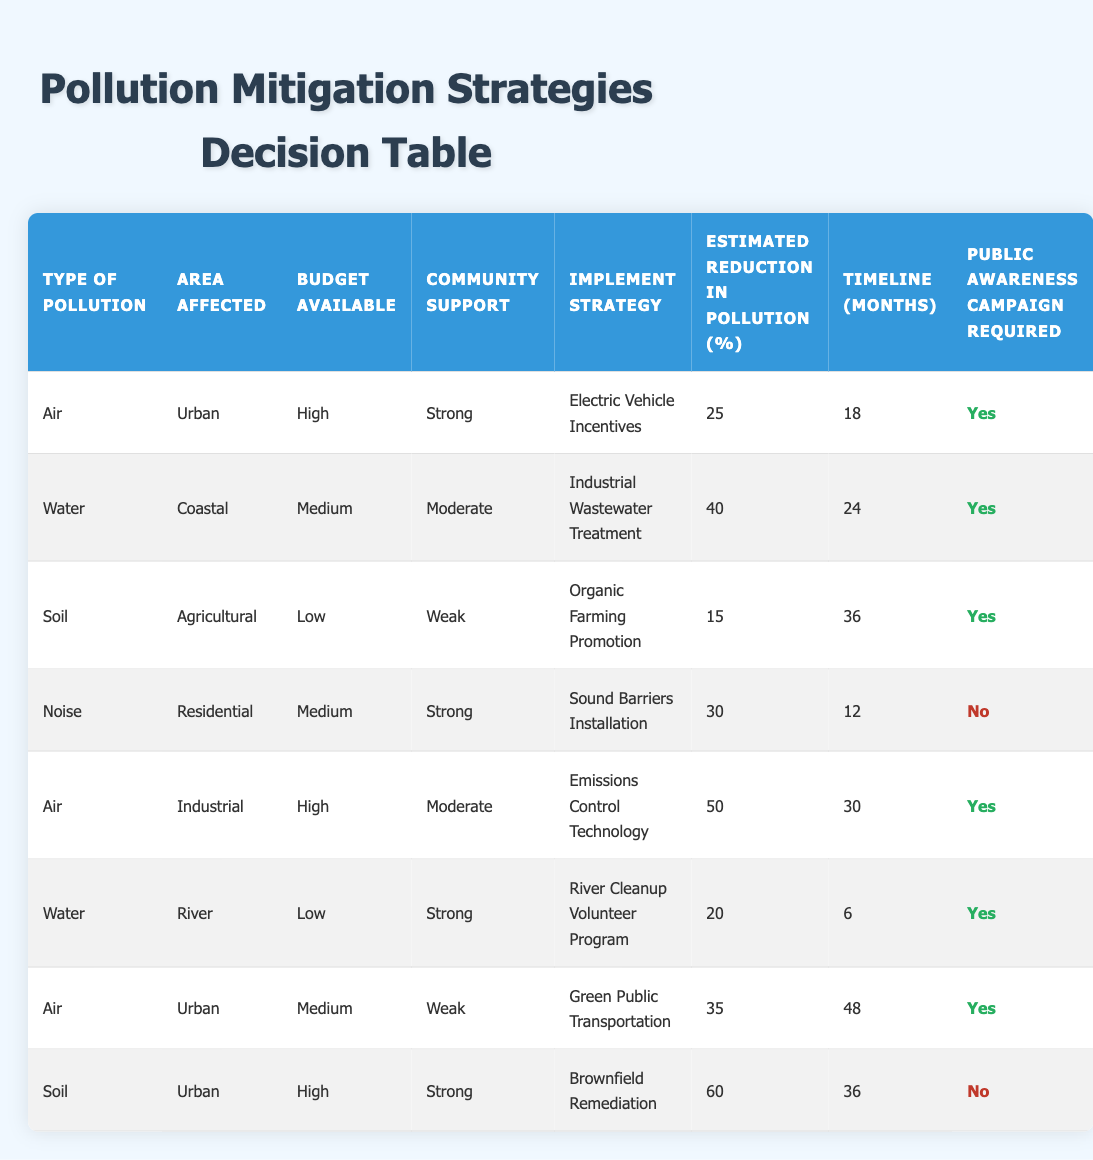What is the estimated reduction in pollution for the "Industrial Wastewater Treatment" strategy? The table lists "Industrial Wastewater Treatment" under the "Implement Strategy" column corresponding to "Water" type pollution and "Coastal" area affected. The "Estimated Reduction in Pollution (%)" for this strategy is given as 40%.
Answer: 40% What is the timeline for implementing the "Sound Barriers Installation" strategy? In the table, "Sound Barriers Installation" is listed under the "Implement Strategy" column for "Noise" type pollution in the "Residential" area. The corresponding "Timeline (months)" is 12 months.
Answer: 12 months Which pollution mitigation strategy has the highest estimated reduction in pollution percentage? By reviewing the "Estimated Reduction in Pollution (%)" column, we see that "Brownfield Remediation" has the highest value at 60%, followed by "Emissions Control Technology" at 50%, and others are lower.
Answer: Brownfield Remediation Is a public awareness campaign required for "Green Public Transportation"? The row for "Green Public Transportation" indicates that it is marked as "Yes" under "Public Awareness Campaign Required". Therefore, a campaign is indeed necessary for this strategy.
Answer: Yes How many strategies require a public awareness campaign? We can find strategies that require a public awareness campaign by counting the rows where the "Public Awareness Campaign Required" column is marked as "Yes". There are 5 strategies that require a campaign: Electric Vehicle Incentives, Industrial Wastewater Treatment, Organic Farming Promotion, River Cleanup Volunteer Program, and Green Public Transportation.
Answer: 5 What is the average estimated reduction in pollution for strategies with a high budget? We first identify the strategies with a "High" budget: Electric Vehicle Incentives (25%), Emissions Control Technology (50%), and Brownfield Remediation (60%). The sum of these reductions is 25 + 50 + 60 = 135%. Dividing this by the number of strategies (3), we get an average of 135/3 = 45%.
Answer: 45% Which area affected has the least community support, and what strategy is associated with it? By looking at the "Community Support" column, we see "Weak" support in the "Agricultural" area, associated with the strategy "Organic Farming Promotion".
Answer: Agricultural area, Organic Farming Promotion Is the estimated reduction in pollution higher for urban areas with medium budgets or for coastal areas with medium budgets? First, we check urban areas with medium budgets: Electric Vehicle Incentives (25% reduction) and Green Public Transportation (35% reduction), giving an average of (25 + 35)/2 = 30%. For coastal areas: Industrial Wastewater Treatment at 40%. Since 40% is higher than 30%, the coastal area has the higher reduction.
Answer: Coastal areas have a higher reduction 